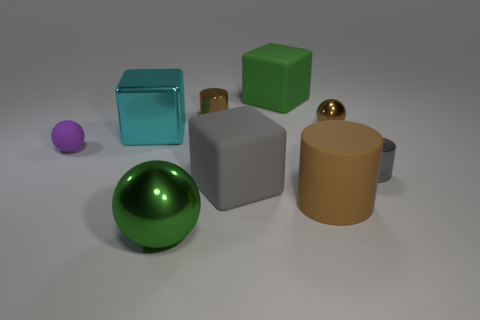Is the number of large blue things greater than the number of tiny brown metal things?
Offer a terse response. No. Are there any other things that are the same color as the big matte cylinder?
Keep it short and to the point. Yes. The tiny purple thing that is the same material as the big gray block is what shape?
Provide a short and direct response. Sphere. There is a thing left of the block that is on the left side of the green metal thing; what is its material?
Your answer should be compact. Rubber. There is a big matte thing that is behind the small matte thing; is it the same shape as the brown rubber object?
Offer a terse response. No. Are there more objects that are to the left of the purple thing than large cyan things?
Your answer should be compact. No. Is there any other thing that is made of the same material as the small purple thing?
Provide a short and direct response. Yes. There is a metallic object that is the same color as the tiny metallic ball; what shape is it?
Ensure brevity in your answer.  Cylinder. What number of cylinders are tiny brown shiny objects or cyan objects?
Give a very brief answer. 1. There is a metallic sphere that is right of the tiny cylinder on the left side of the large green matte object; what is its color?
Keep it short and to the point. Brown. 